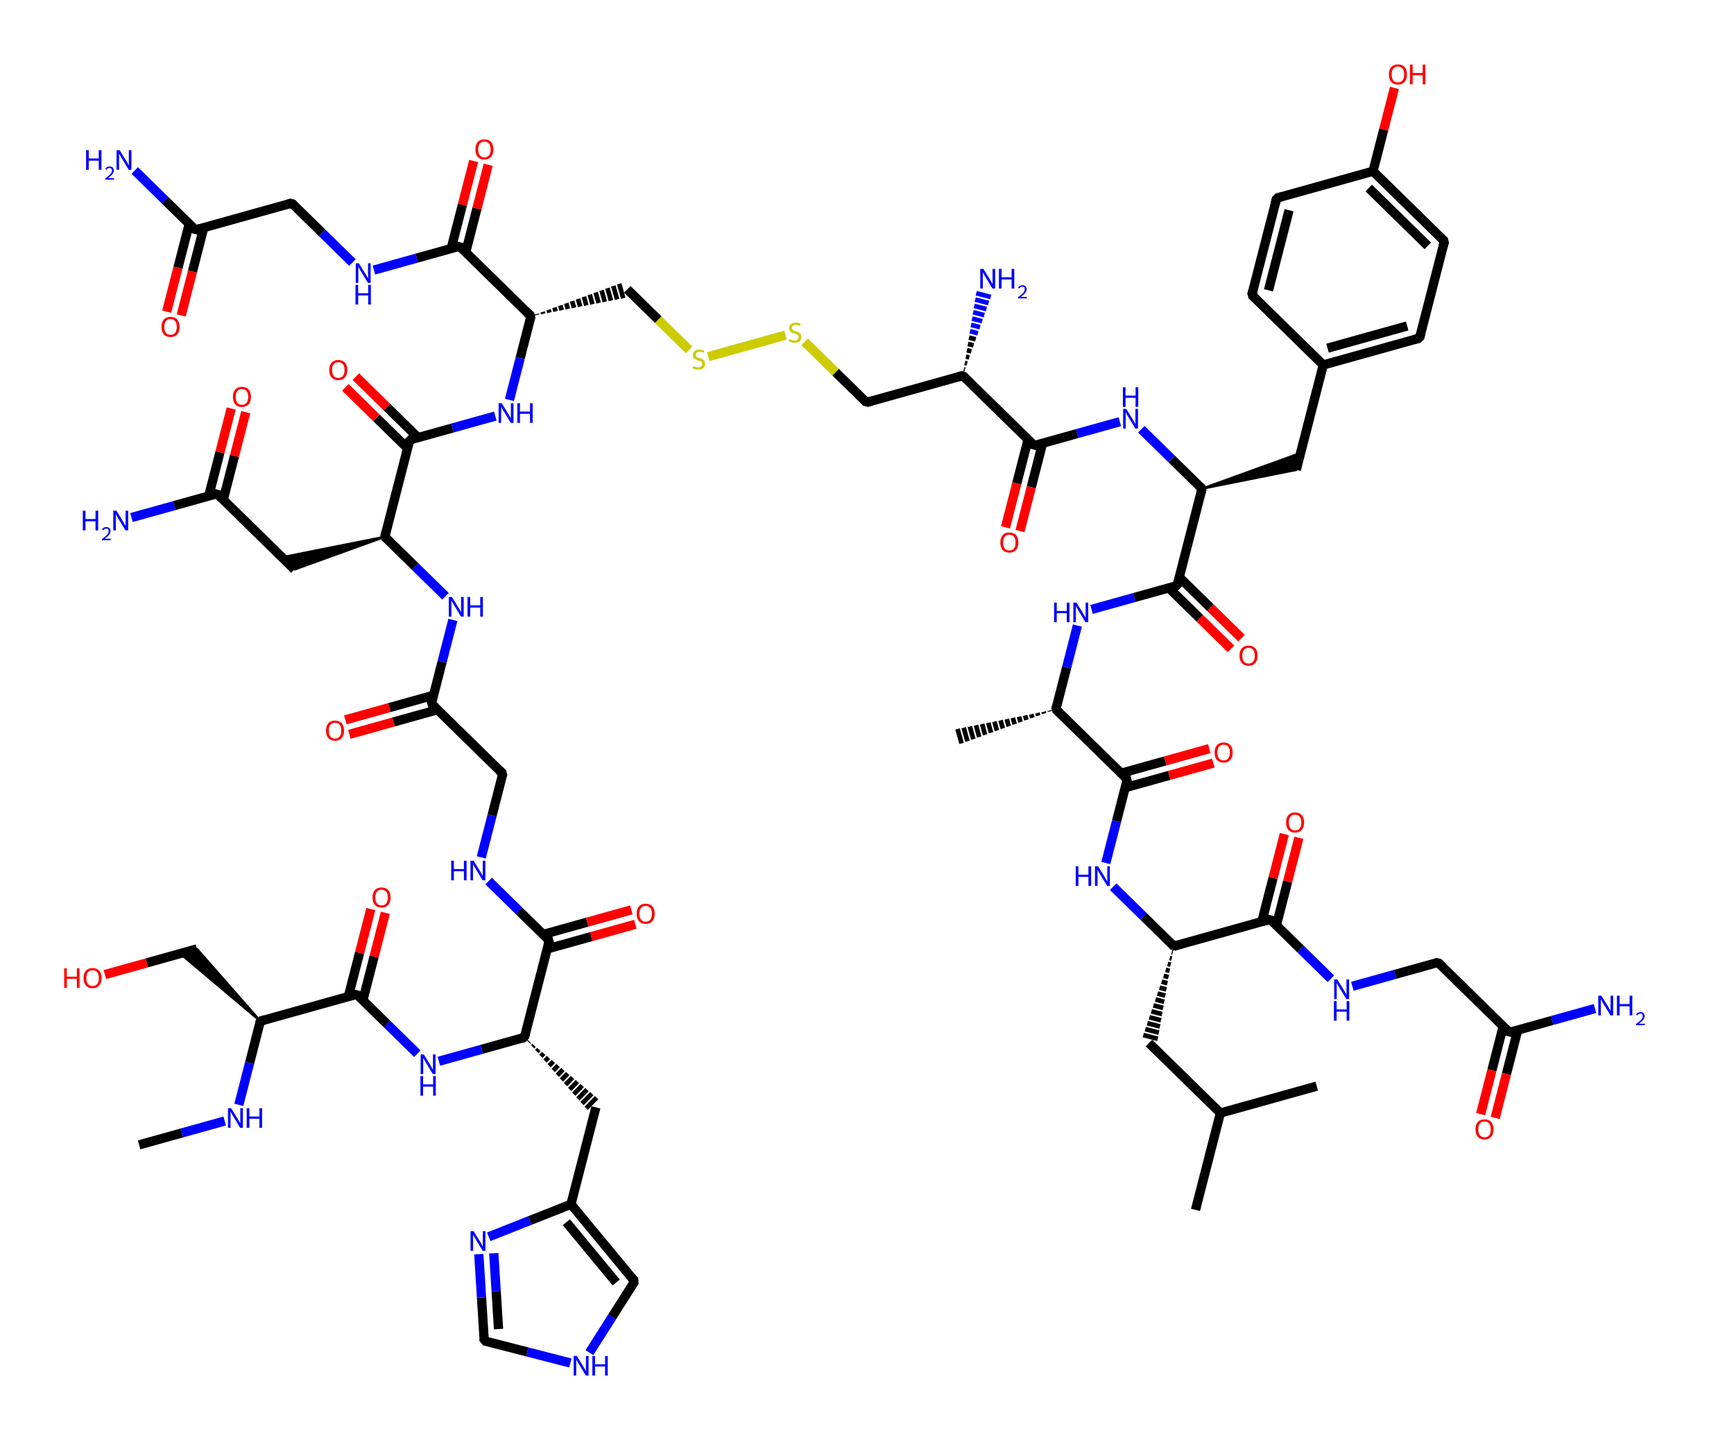What is the molecular formula of oxytocin based on its structure? By examining the SMILES representation, we can count the total numbers of carbon (C), hydrogen (H), nitrogen (N), oxygen (O), and sulfur (S) atoms present. The breakdown of the counts reveals the formula is C43H66N12O12S2.
Answer: C43H66N12O12S2 How many nitrogen atoms are present in oxytocin? Looking at the SMILES representation, we can identify each occurrence of nitrogen atoms (represented by "N"). Counting these, we find there are 12 nitrogen atoms in the molecule.
Answer: 12 What is the function of oxytocin in the human body? Oxytocin is commonly known as the "love hormone" or "bonding hormone," which plays a significant role in social bonding, emotional regulation, and reproduction. This is well-established in biology and psychology literature.
Answer: love hormone How many total rings are in the oxytocin structure? Observing the structure derived from the SMILES notation, there are two distinct cyclic structures (indicated by interlinked atoms) visible in the chemical makeup of oxytocin. Hence, the answer reveals the total count of rings.
Answer: 2 What type of chemical compound is oxytocin categorized as? Analyzing the structure, oxytocin is understood to be a peptide hormone made up of a sequence of amino acids. By recognizing the peptides' defining characteristics, we determine this classification.
Answer: peptide hormone 